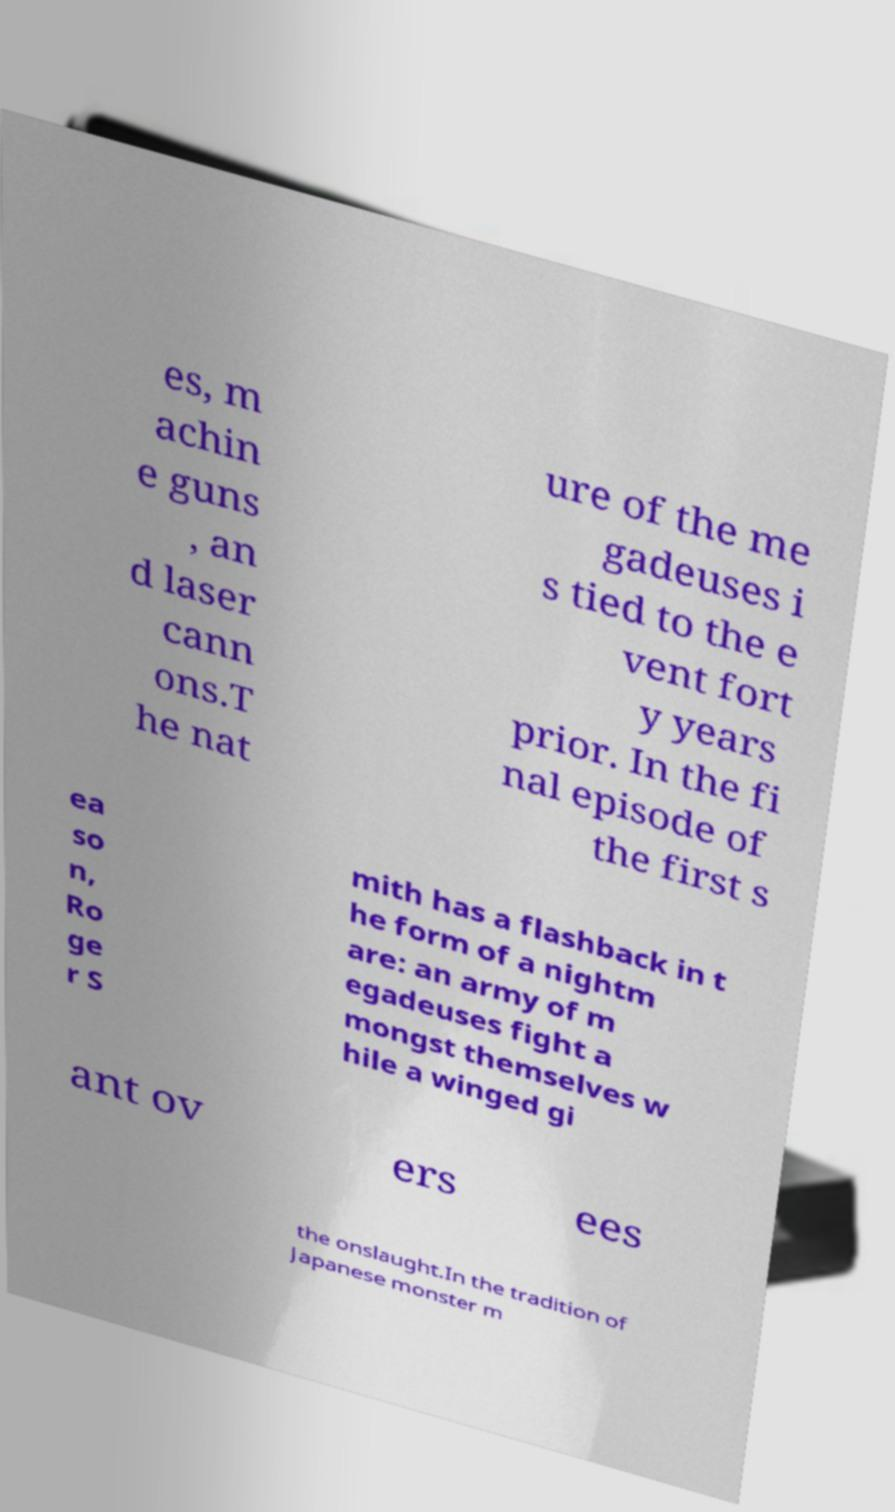For documentation purposes, I need the text within this image transcribed. Could you provide that? es, m achin e guns , an d laser cann ons.T he nat ure of the me gadeuses i s tied to the e vent fort y years prior. In the fi nal episode of the first s ea so n, Ro ge r S mith has a flashback in t he form of a nightm are: an army of m egadeuses fight a mongst themselves w hile a winged gi ant ov ers ees the onslaught.In the tradition of Japanese monster m 